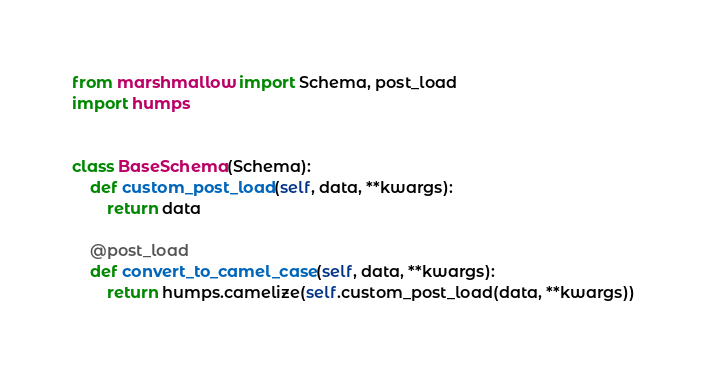Convert code to text. <code><loc_0><loc_0><loc_500><loc_500><_Python_>from marshmallow import Schema, post_load
import humps


class BaseSchema(Schema):
    def custom_post_load(self, data, **kwargs):
        return data

    @post_load
    def convert_to_camel_case(self, data, **kwargs):
        return humps.camelize(self.custom_post_load(data, **kwargs))
</code> 